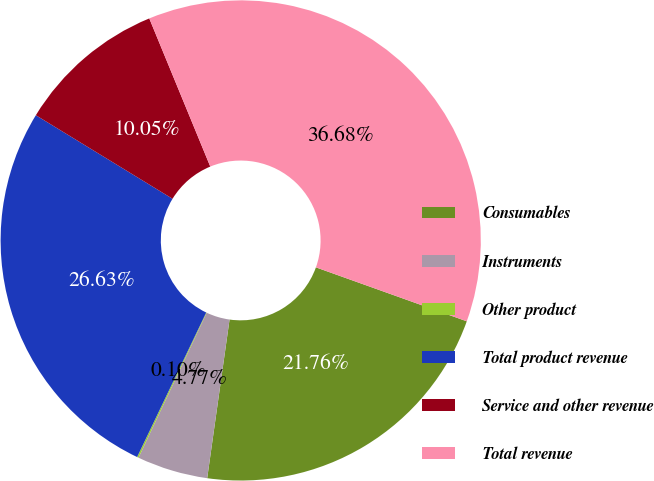Convert chart. <chart><loc_0><loc_0><loc_500><loc_500><pie_chart><fcel>Consumables<fcel>Instruments<fcel>Other product<fcel>Total product revenue<fcel>Service and other revenue<fcel>Total revenue<nl><fcel>21.76%<fcel>4.77%<fcel>0.1%<fcel>26.63%<fcel>10.05%<fcel>36.68%<nl></chart> 